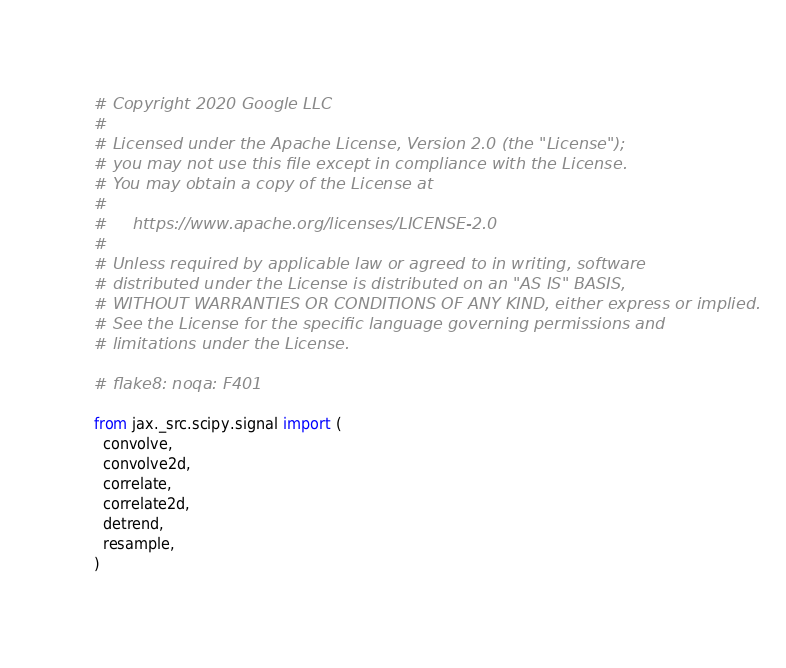Convert code to text. <code><loc_0><loc_0><loc_500><loc_500><_Python_># Copyright 2020 Google LLC
#
# Licensed under the Apache License, Version 2.0 (the "License");
# you may not use this file except in compliance with the License.
# You may obtain a copy of the License at
#
#     https://www.apache.org/licenses/LICENSE-2.0
#
# Unless required by applicable law or agreed to in writing, software
# distributed under the License is distributed on an "AS IS" BASIS,
# WITHOUT WARRANTIES OR CONDITIONS OF ANY KIND, either express or implied.
# See the License for the specific language governing permissions and
# limitations under the License.

# flake8: noqa: F401

from jax._src.scipy.signal import (
  convolve,
  convolve2d,
  correlate,
  correlate2d,
  detrend,
  resample,
)
</code> 